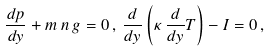<formula> <loc_0><loc_0><loc_500><loc_500>\frac { d p } { d y } + m \, n \, g = 0 \, , \, \frac { d } { d y } \left ( \kappa \, \frac { d } { d y } T \right ) - I = 0 \, ,</formula> 